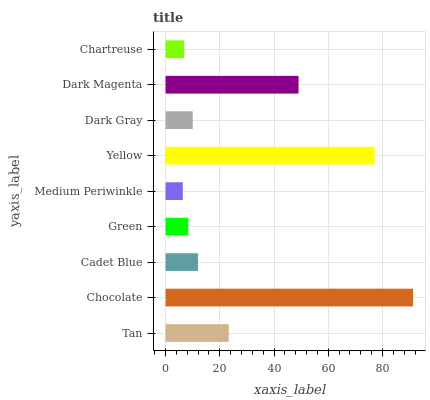Is Medium Periwinkle the minimum?
Answer yes or no. Yes. Is Chocolate the maximum?
Answer yes or no. Yes. Is Cadet Blue the minimum?
Answer yes or no. No. Is Cadet Blue the maximum?
Answer yes or no. No. Is Chocolate greater than Cadet Blue?
Answer yes or no. Yes. Is Cadet Blue less than Chocolate?
Answer yes or no. Yes. Is Cadet Blue greater than Chocolate?
Answer yes or no. No. Is Chocolate less than Cadet Blue?
Answer yes or no. No. Is Cadet Blue the high median?
Answer yes or no. Yes. Is Cadet Blue the low median?
Answer yes or no. Yes. Is Green the high median?
Answer yes or no. No. Is Medium Periwinkle the low median?
Answer yes or no. No. 